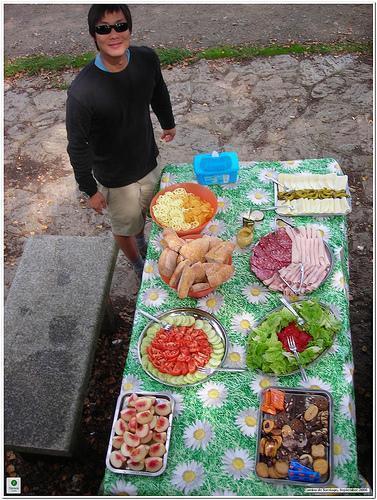How many people are in the picture?
Give a very brief answer. 1. 